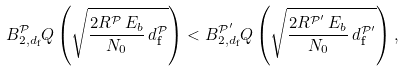<formula> <loc_0><loc_0><loc_500><loc_500>B ^ { \mathcal { P } } _ { 2 , d _ { \text {f} } } Q \left ( \sqrt { \frac { 2 R ^ { \mathcal { P } } \, E _ { b } } { N _ { 0 } } \, d ^ { \mathcal { P } } _ { \text {f} } } \right ) < B ^ { \mathcal { P } ^ { \prime } } _ { 2 , d _ { \text {f} } } Q \left ( \sqrt { \frac { 2 R ^ { \mathcal { P } ^ { \prime } } \, E _ { b } } { N _ { 0 } } \, d ^ { \mathcal { P } ^ { \prime } } _ { \text {f} } } \right ) ,</formula> 